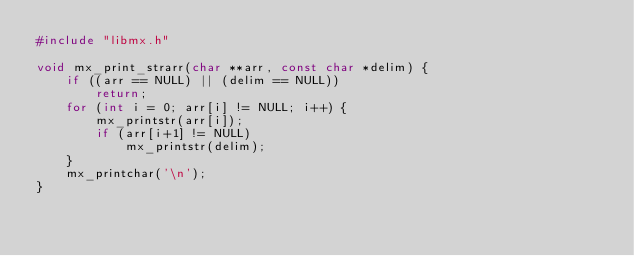Convert code to text. <code><loc_0><loc_0><loc_500><loc_500><_C_>#include "libmx.h"

void mx_print_strarr(char **arr, const char *delim) {
    if ((arr == NULL) || (delim == NULL))
        return;
    for (int i = 0; arr[i] != NULL; i++) {
        mx_printstr(arr[i]);
        if (arr[i+1] != NULL)
            mx_printstr(delim);
    }
    mx_printchar('\n');
}
</code> 